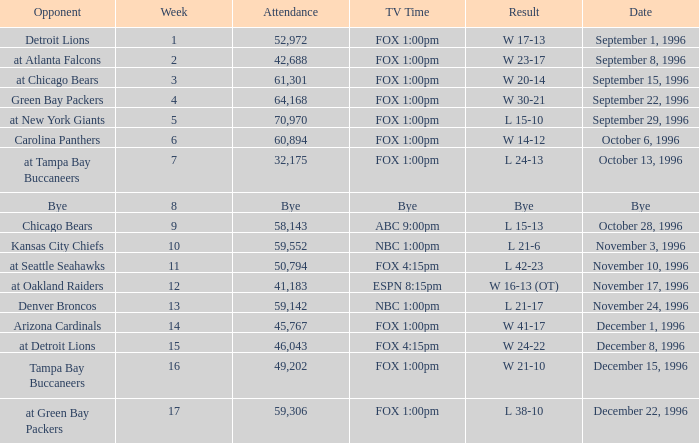Tell me the opponent for november 24, 1996 Denver Broncos. 